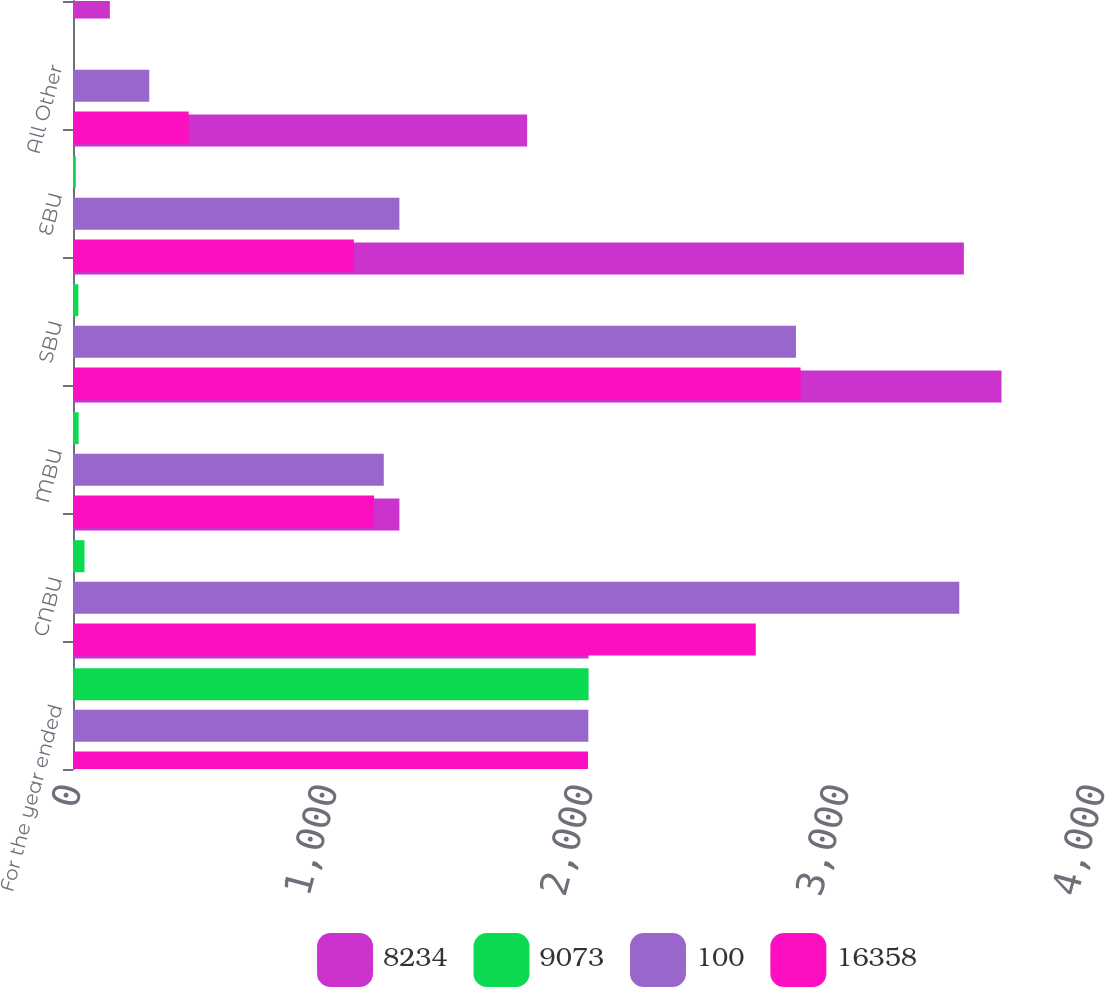<chart> <loc_0><loc_0><loc_500><loc_500><stacked_bar_chart><ecel><fcel>For the year ended<fcel>CNBU<fcel>MBU<fcel>SBU<fcel>EBU<fcel>All Other<nl><fcel>8234<fcel>2014<fcel>1275<fcel>3627<fcel>3480<fcel>1774<fcel>144<nl><fcel>9073<fcel>2014<fcel>45<fcel>22<fcel>21<fcel>11<fcel>1<nl><fcel>100<fcel>2013<fcel>3462<fcel>1214<fcel>2824<fcel>1275<fcel>298<nl><fcel>16358<fcel>2012<fcel>2667<fcel>1176<fcel>2842<fcel>1097<fcel>452<nl></chart> 